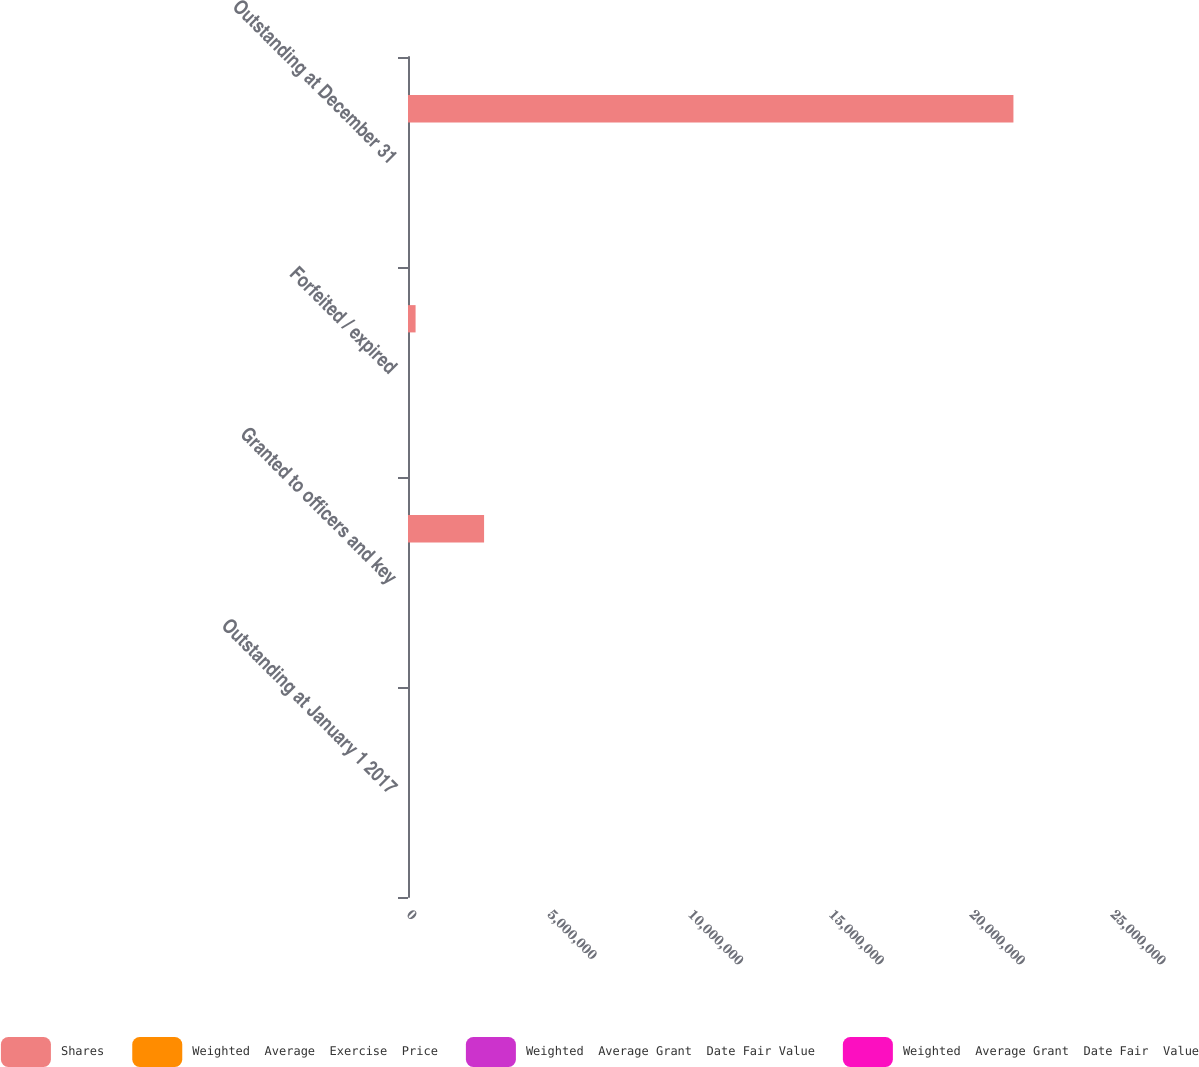Convert chart to OTSL. <chart><loc_0><loc_0><loc_500><loc_500><stacked_bar_chart><ecel><fcel>Outstanding at January 1 2017<fcel>Granted to officers and key<fcel>Forfeited / expired<fcel>Outstanding at December 31<nl><fcel>Shares<fcel>86.78<fcel>2.70164e+06<fcel>269334<fcel>2.14999e+07<nl><fcel>Weighted  Average  Exercise  Price<fcel>82.13<fcel>95.66<fcel>94.23<fcel>86.86<nl><fcel>Weighted  Average Grant  Date Fair Value<fcel>78.5<fcel>90.11<fcel>79.43<fcel>80.04<nl><fcel>Weighted  Average Grant  Date Fair  Value<fcel>66.92<fcel>86.78<fcel>78.14<fcel>74.06<nl></chart> 